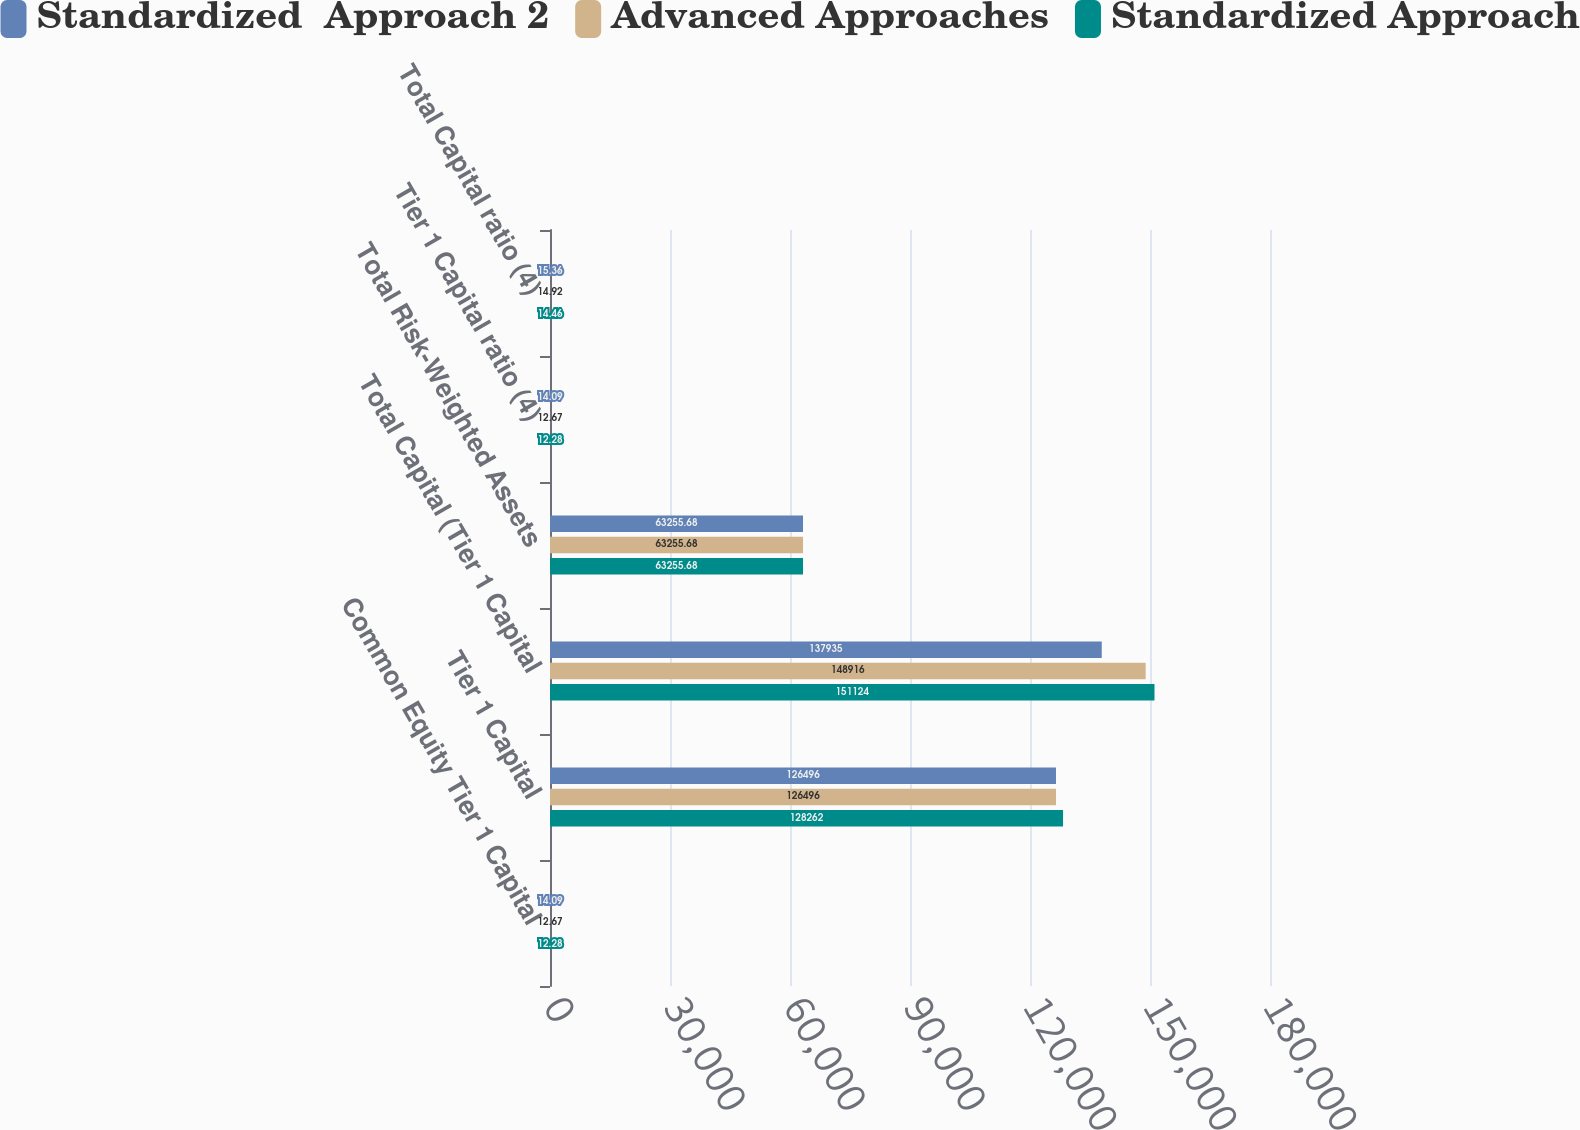Convert chart to OTSL. <chart><loc_0><loc_0><loc_500><loc_500><stacked_bar_chart><ecel><fcel>Common Equity Tier 1 Capital<fcel>Tier 1 Capital<fcel>Total Capital (Tier 1 Capital<fcel>Total Risk-Weighted Assets<fcel>Tier 1 Capital ratio (4)<fcel>Total Capital ratio (4)<nl><fcel>Standardized  Approach 2<fcel>14.09<fcel>126496<fcel>137935<fcel>63255.7<fcel>14.09<fcel>15.36<nl><fcel>Advanced Approaches<fcel>12.67<fcel>126496<fcel>148916<fcel>63255.7<fcel>12.67<fcel>14.92<nl><fcel>Standardized Approach<fcel>12.28<fcel>128262<fcel>151124<fcel>63255.7<fcel>12.28<fcel>14.46<nl></chart> 